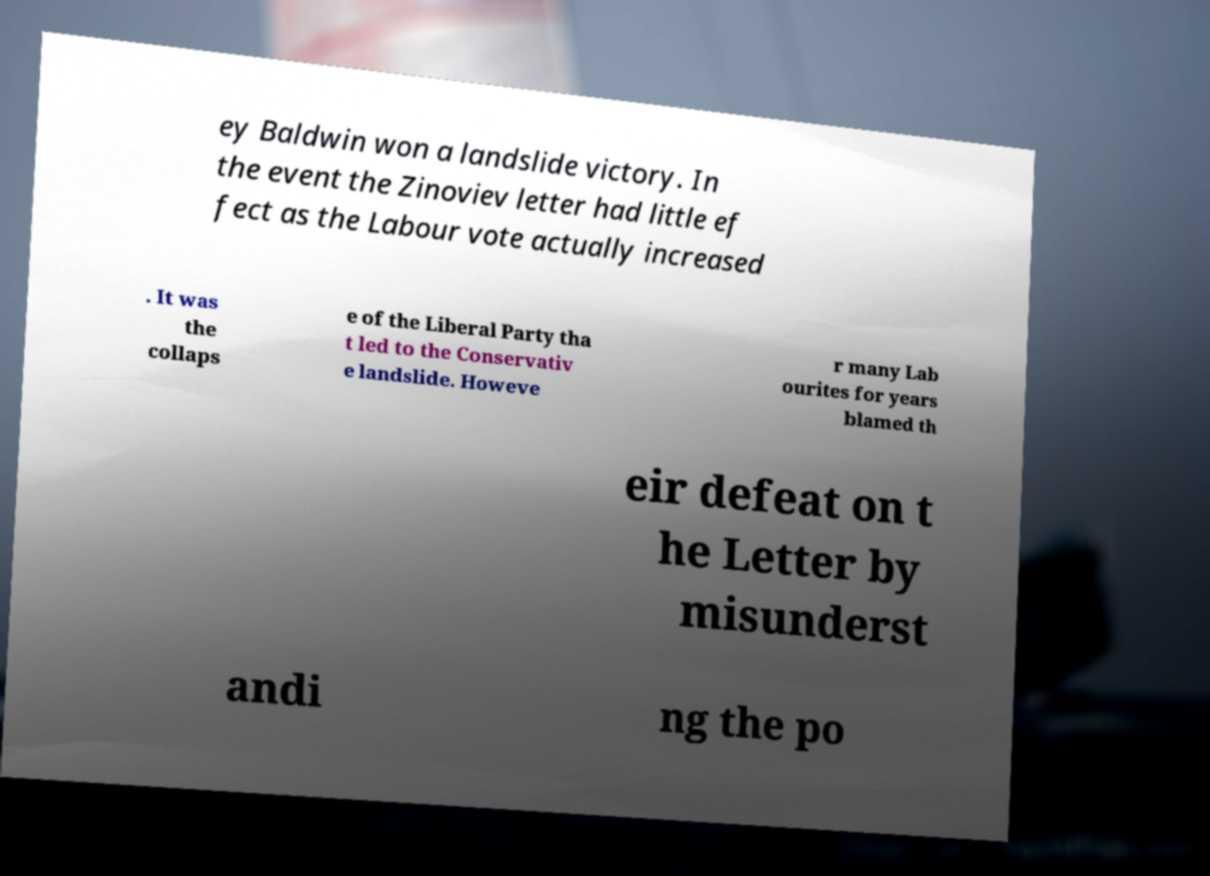Can you accurately transcribe the text from the provided image for me? ey Baldwin won a landslide victory. In the event the Zinoviev letter had little ef fect as the Labour vote actually increased . It was the collaps e of the Liberal Party tha t led to the Conservativ e landslide. Howeve r many Lab ourites for years blamed th eir defeat on t he Letter by misunderst andi ng the po 